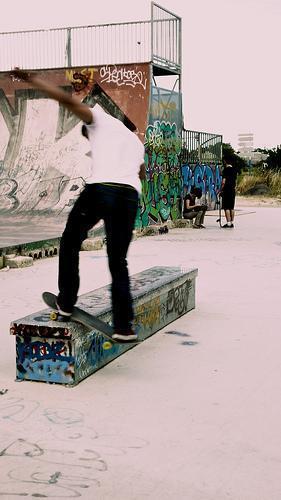How many people are skateboarding?
Give a very brief answer. 1. 